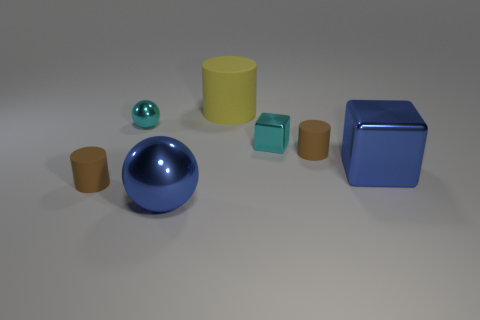Are there any blue spheres that have the same material as the small cyan cube?
Your response must be concise. Yes. Are there fewer tiny metal spheres that are behind the big yellow matte cylinder than brown matte things?
Your response must be concise. Yes. What is the material of the tiny brown cylinder left of the shiny object left of the big shiny ball?
Your answer should be compact. Rubber. There is a object that is behind the small metallic block and on the left side of the big yellow thing; what is its shape?
Provide a succinct answer. Sphere. What number of other things are the same color as the big rubber object?
Offer a very short reply. 0. How many things are small brown cylinders that are on the right side of the yellow cylinder or brown things?
Your answer should be very brief. 2. There is a tiny block; does it have the same color as the object to the left of the cyan metallic sphere?
Make the answer very short. No. Are there any other things that have the same size as the cyan metallic ball?
Your answer should be very brief. Yes. What size is the cyan shiny cube behind the small brown object right of the large blue sphere?
Your response must be concise. Small. How many objects are small gray cubes or rubber cylinders right of the tiny metal sphere?
Ensure brevity in your answer.  2. 